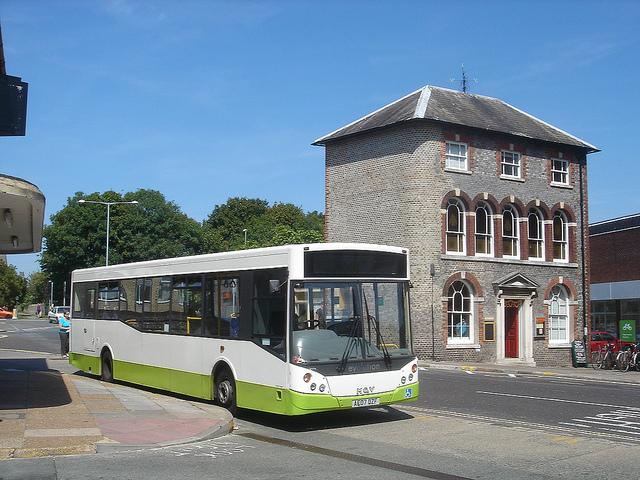Is the bus moving?
Give a very brief answer. No. What is the bus for?
Give a very brief answer. Transportation. How many bus do you see?
Answer briefly. 1. 